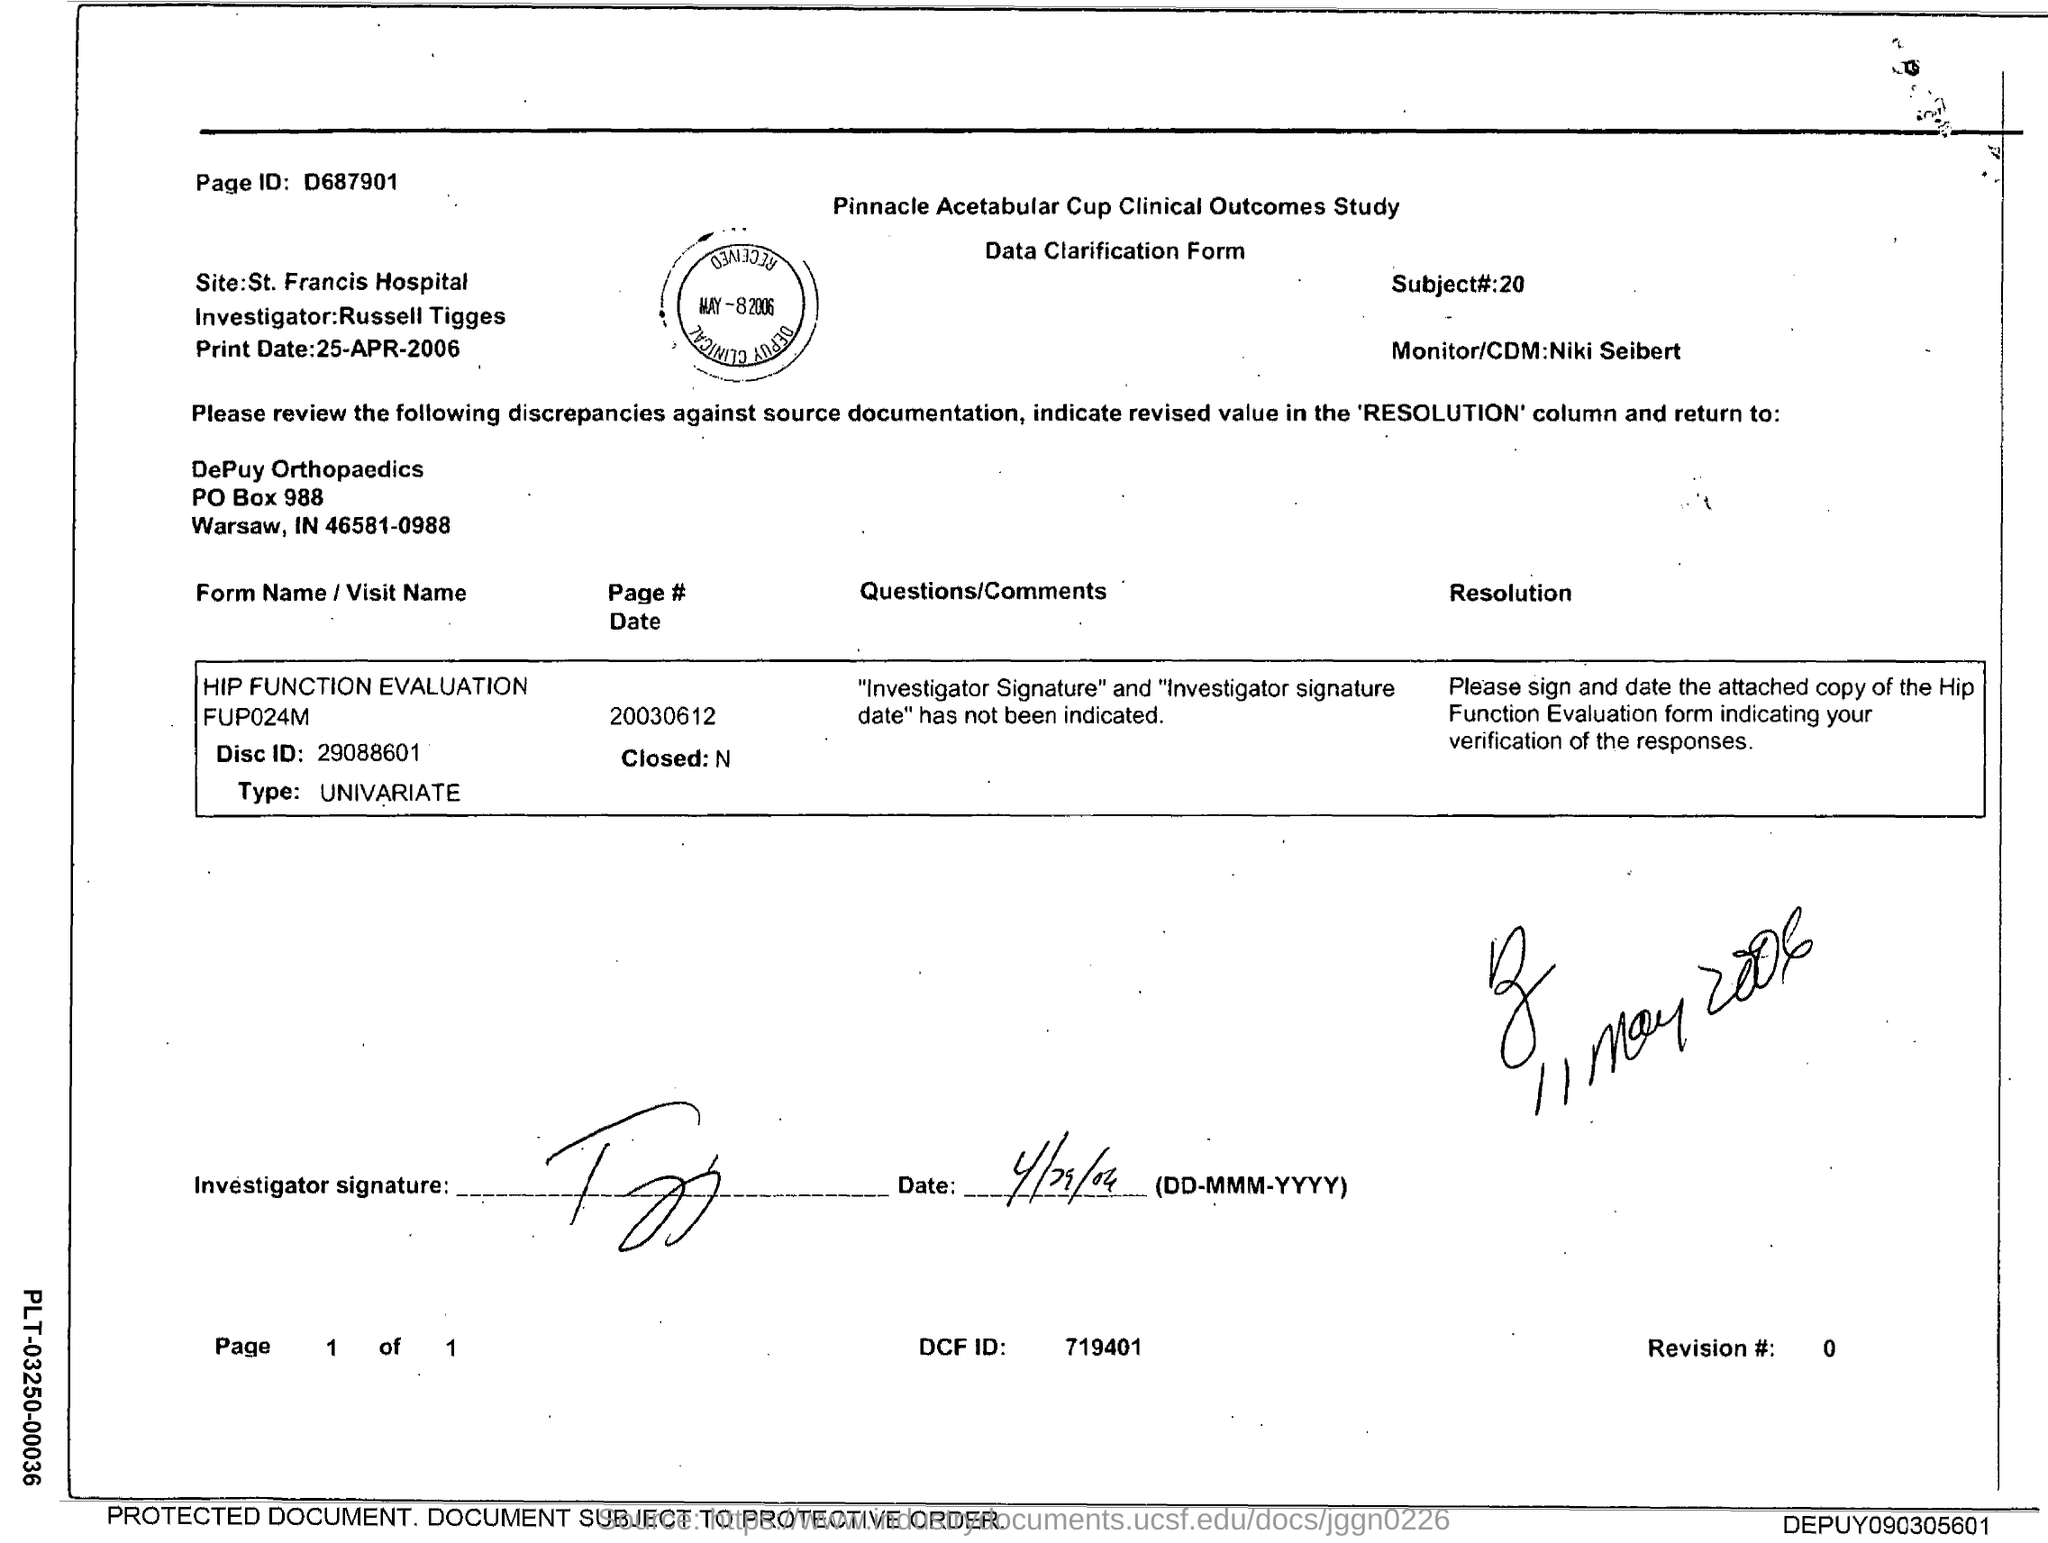What is the page ID given in the form?
Ensure brevity in your answer.  D687901. What type of form is given here?
Offer a terse response. Data Clarification Form. What is the subject# mentioned in the form?
Provide a succinct answer. 20. Who is the Monitor/CDM as mentioned in the form?
Provide a succinct answer. Niki Seibert. What is the Disc ID mentioned in the form?
Offer a very short reply. 29088601. Who is the Investigator as per the form?
Your answer should be very brief. Russell Tigges. What is the print date of the data clarification form?
Provide a short and direct response. 25-APR-2006. What is the DCF ID given in the form?
Ensure brevity in your answer.  719401. What is the revision # mentioned in the form?
Keep it short and to the point. 0. 